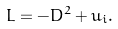<formula> <loc_0><loc_0><loc_500><loc_500>L = - D ^ { 2 } + u _ { i } .</formula> 